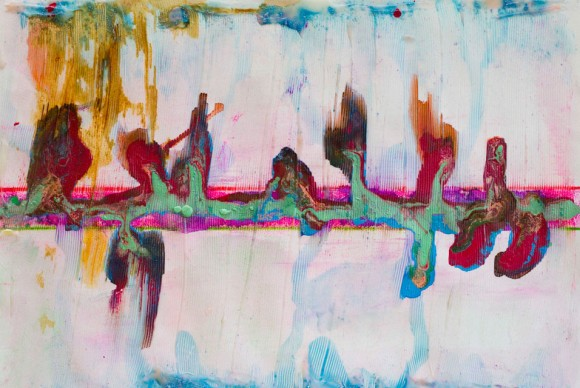How does the use of color in this piece influence its overall impact? The use of color in this piece plays a crucial role in shaping its overall impact. The predominantly pastel palette imparts a sense of calm and softness, creating a soothing and inviting visual experience. These gentle hues evoke feelings of tranquility and peace. In contrast, the interspersed darker shades introduce elements of depth and complexity, which add a layer of intrigue and tension to the composition. This interplay between light and dark colors creates a dynamic balance, enhancing the artwork's ability to captivate and engage the viewer. Moreover, the vibrant bursts of color punctuate the softer tones, drawing attention to specific areas and adding focal points that guide the viewer's eye across the canvas. This thoughtful use of color not only enhances the aesthetic appeal but also reinforces the abstract nature of the piece, allowing for multiple interpretations and emotional responses. Describe how this painting might be used in a modern home decor setting. In a modern home decor setting, this painting would serve as a striking focal point in any room. Its abstract design and vibrant color palette make it a versatile piece that can complement various interior styles. Placed in a living room, it could draw attention and spark conversation, especially when hung above a neutral-colored sofa or fireplace. The soothing pastel tones can harmonize with minimalist furniture, while the dynamic elements add a touch of liveliness, breaking the monotony. In a bedroom, it could create a serene and dreamlike atmosphere, promoting relaxation and creativity. The artwork's blend of colors and textures can tie together different decor elements, such as throw pillows, rugs, and accessories, creating a cohesive and sophisticated look. Overall, this painting's contemporary and abstract qualities make it a perfect addition to modern home decor, enhancing both aesthetics and ambiance. 